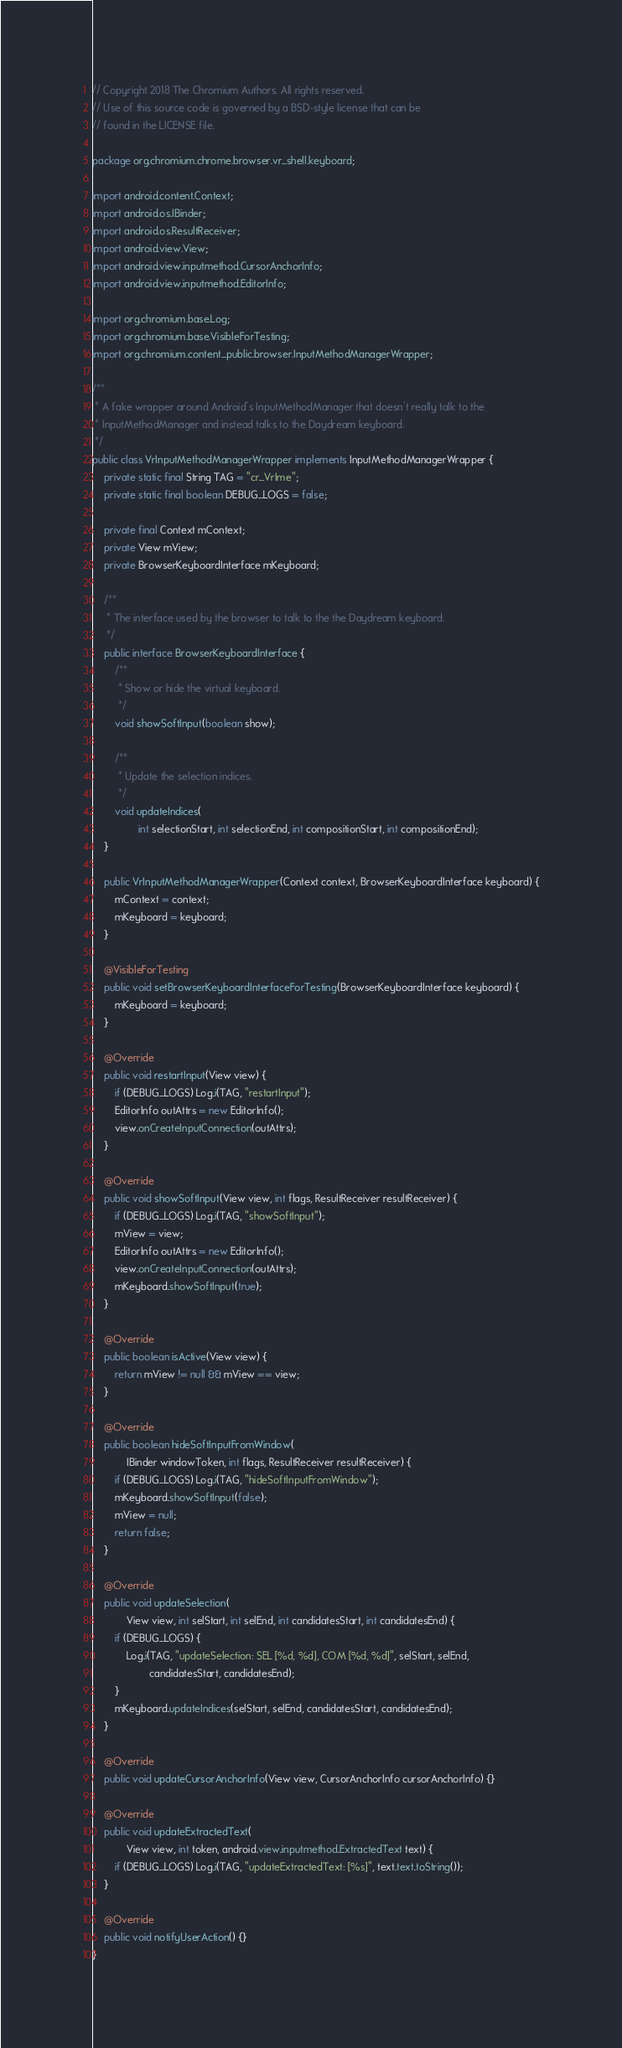Convert code to text. <code><loc_0><loc_0><loc_500><loc_500><_Java_>// Copyright 2018 The Chromium Authors. All rights reserved.
// Use of this source code is governed by a BSD-style license that can be
// found in the LICENSE file.

package org.chromium.chrome.browser.vr_shell.keyboard;

import android.content.Context;
import android.os.IBinder;
import android.os.ResultReceiver;
import android.view.View;
import android.view.inputmethod.CursorAnchorInfo;
import android.view.inputmethod.EditorInfo;

import org.chromium.base.Log;
import org.chromium.base.VisibleForTesting;
import org.chromium.content_public.browser.InputMethodManagerWrapper;

/**
 * A fake wrapper around Android's InputMethodManager that doesn't really talk to the
 * InputMethodManager and instead talks to the Daydream keyboard.
 */
public class VrInputMethodManagerWrapper implements InputMethodManagerWrapper {
    private static final String TAG = "cr_VrIme";
    private static final boolean DEBUG_LOGS = false;

    private final Context mContext;
    private View mView;
    private BrowserKeyboardInterface mKeyboard;

    /**
     * The interface used by the browser to talk to the the Daydream keyboard.
     */
    public interface BrowserKeyboardInterface {
        /**
         * Show or hide the virtual keyboard.
         */
        void showSoftInput(boolean show);

        /**
         * Update the selection indices.
         */
        void updateIndices(
                int selectionStart, int selectionEnd, int compositionStart, int compositionEnd);
    }

    public VrInputMethodManagerWrapper(Context context, BrowserKeyboardInterface keyboard) {
        mContext = context;
        mKeyboard = keyboard;
    }

    @VisibleForTesting
    public void setBrowserKeyboardInterfaceForTesting(BrowserKeyboardInterface keyboard) {
        mKeyboard = keyboard;
    }

    @Override
    public void restartInput(View view) {
        if (DEBUG_LOGS) Log.i(TAG, "restartInput");
        EditorInfo outAttrs = new EditorInfo();
        view.onCreateInputConnection(outAttrs);
    }

    @Override
    public void showSoftInput(View view, int flags, ResultReceiver resultReceiver) {
        if (DEBUG_LOGS) Log.i(TAG, "showSoftInput");
        mView = view;
        EditorInfo outAttrs = new EditorInfo();
        view.onCreateInputConnection(outAttrs);
        mKeyboard.showSoftInput(true);
    }

    @Override
    public boolean isActive(View view) {
        return mView != null && mView == view;
    }

    @Override
    public boolean hideSoftInputFromWindow(
            IBinder windowToken, int flags, ResultReceiver resultReceiver) {
        if (DEBUG_LOGS) Log.i(TAG, "hideSoftInputFromWindow");
        mKeyboard.showSoftInput(false);
        mView = null;
        return false;
    }

    @Override
    public void updateSelection(
            View view, int selStart, int selEnd, int candidatesStart, int candidatesEnd) {
        if (DEBUG_LOGS) {
            Log.i(TAG, "updateSelection: SEL [%d, %d], COM [%d, %d]", selStart, selEnd,
                    candidatesStart, candidatesEnd);
        }
        mKeyboard.updateIndices(selStart, selEnd, candidatesStart, candidatesEnd);
    }

    @Override
    public void updateCursorAnchorInfo(View view, CursorAnchorInfo cursorAnchorInfo) {}

    @Override
    public void updateExtractedText(
            View view, int token, android.view.inputmethod.ExtractedText text) {
        if (DEBUG_LOGS) Log.i(TAG, "updateExtractedText: [%s]", text.text.toString());
    }

    @Override
    public void notifyUserAction() {}
}
</code> 